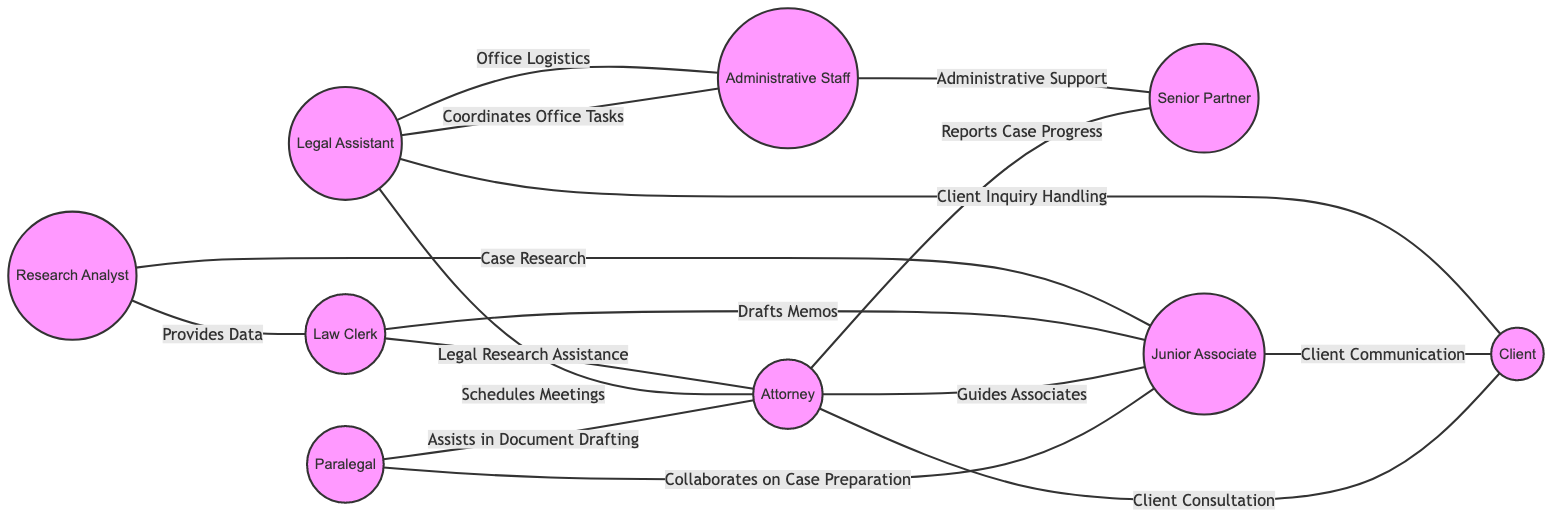What is the total number of nodes in the diagram? To find the total number of nodes, count each distinct entity represented in the diagram. The entities are Paralegal, Attorney, Senior Partner, Junior Associate, Legal Assistant, Client, Law Clerk, Administrative Staff, and Research Analyst. This gives us a total of 9 nodes.
Answer: 9 Who collaborates with the Junior Associate? The Junior Associate has connections with both the Paralegal and the Attorney through the edges labeled "Collaborates on Case Preparation" and "Guides Associates." Therefore, the entities that collaborate with the Junior Associate are the Paralegal and the Attorney.
Answer: Paralegal, Attorney How many edges are incident to the Attorney? An edge is incident to a node if it connects to that node. The Attorney is connected by three edges: one to the Paralegal (Document Drafting), one to the Junior Associate (Guides Associates), and one to the Client (Client Consultation). Thus, there are 3 edges incident to the Attorney.
Answer: 3 Which node has the most connections? The node with the most connections can be determined by counting the number of edges connected to each node. The Attorney has 3 connections, the Junior Associate has 3 as well, while others have fewer. Thus, both the Attorney and Junior Associate are tied with the most connections at 3 each.
Answer: Attorney, Junior Associate What is the relationship between the Law Clerk and the Attorney? The Law Clerk has a connection with the Attorney through the edge labeled "Legal Research Assistance." This indicates that the Law Clerk assists the Attorney in matters related to legal research.
Answer: Legal Research Assistance How does the Legal Assistant support the Attorney? The Legal Assistant supports the Attorney through the edge labeled "Schedules Meetings," indicating that they handle the scheduling of meetings for the Attorney. This depicts a supportive role in the Attorney's workflow.
Answer: Schedules Meetings Which roles are involved in client communication? Client communication involves the Attorney and Junior Associate, as represented by the edges labeled "Client Consultation" (Attorney) and "Client Communication" (Junior Associate). Thus, these two roles are directly involved in client communication.
Answer: Attorney, Junior Associate What type of support does the Administrative Staff provide to the Senior Partner? The Administrative Staff provides "Administrative Support" to the Senior Partner, as indicated by the edge between the two. This suggests that the Administrative Staff performs tasks to assist the Senior Partner in managing their responsibilities.
Answer: Administrative Support 